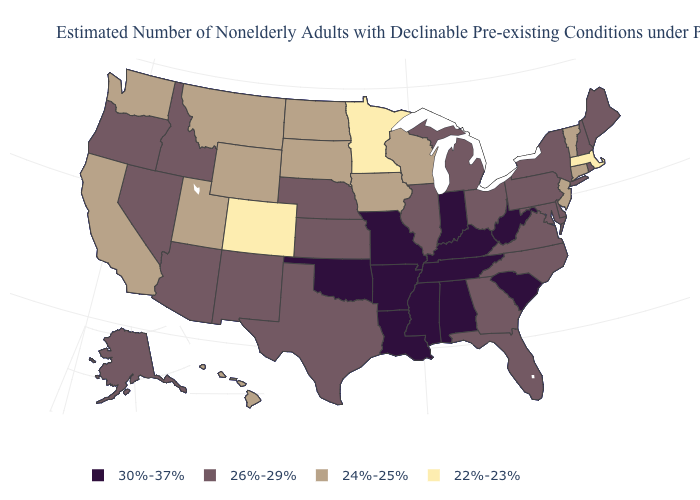Does Colorado have the lowest value in the West?
Answer briefly. Yes. Name the states that have a value in the range 24%-25%?
Concise answer only. California, Connecticut, Hawaii, Iowa, Montana, New Jersey, North Dakota, South Dakota, Utah, Vermont, Washington, Wisconsin, Wyoming. Does Minnesota have the highest value in the USA?
Quick response, please. No. What is the value of Minnesota?
Write a very short answer. 22%-23%. What is the value of Kansas?
Be succinct. 26%-29%. Which states have the lowest value in the USA?
Quick response, please. Colorado, Massachusetts, Minnesota. Does Rhode Island have the lowest value in the Northeast?
Give a very brief answer. No. Which states have the lowest value in the USA?
Write a very short answer. Colorado, Massachusetts, Minnesota. Name the states that have a value in the range 26%-29%?
Be succinct. Alaska, Arizona, Delaware, Florida, Georgia, Idaho, Illinois, Kansas, Maine, Maryland, Michigan, Nebraska, Nevada, New Hampshire, New Mexico, New York, North Carolina, Ohio, Oregon, Pennsylvania, Rhode Island, Texas, Virginia. What is the lowest value in the Northeast?
Keep it brief. 22%-23%. Does the map have missing data?
Give a very brief answer. No. What is the value of Wyoming?
Write a very short answer. 24%-25%. Is the legend a continuous bar?
Concise answer only. No. Which states hav the highest value in the Northeast?
Answer briefly. Maine, New Hampshire, New York, Pennsylvania, Rhode Island. Name the states that have a value in the range 30%-37%?
Keep it brief. Alabama, Arkansas, Indiana, Kentucky, Louisiana, Mississippi, Missouri, Oklahoma, South Carolina, Tennessee, West Virginia. 